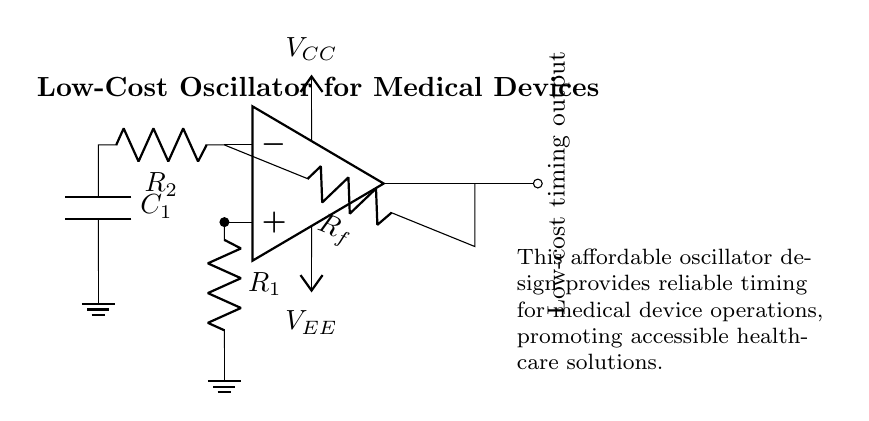What type of oscillator is shown in the circuit? The circuit is a relaxation oscillator, which typically uses an operational amplifier and an RC network to generate a square wave output.
Answer: relaxation oscillator What components are used in this oscillator circuit? The circuit includes an operational amplifier, resistors, and a capacitor, essential for the timing function of the oscillator.
Answer: operational amplifier, resistors, capacitor What is the function of the resistor labeled R_f? The resistor R_f is a feedback resistor that regulates the gain of the operational amplifier, ensuring stable oscillation.
Answer: feedback resistor How many resistors are used in this circuit? The circuit has three resistors: R_1, R_2, and R_f, which are crucial for timing and feedback operations.
Answer: three What is the purpose of the capacitor C_1? The capacitor C_1 stores charge and influences the timing interval of the oscillation, working with the resistors to determine frequency.
Answer: timing interval What can we infer about the power supply in the circuit? The circuit is powered by dual voltage supplies: V_CC for positive and V_EE for negative operation, necessary for the op-amp to function effectively.
Answer: dual voltage supplies 